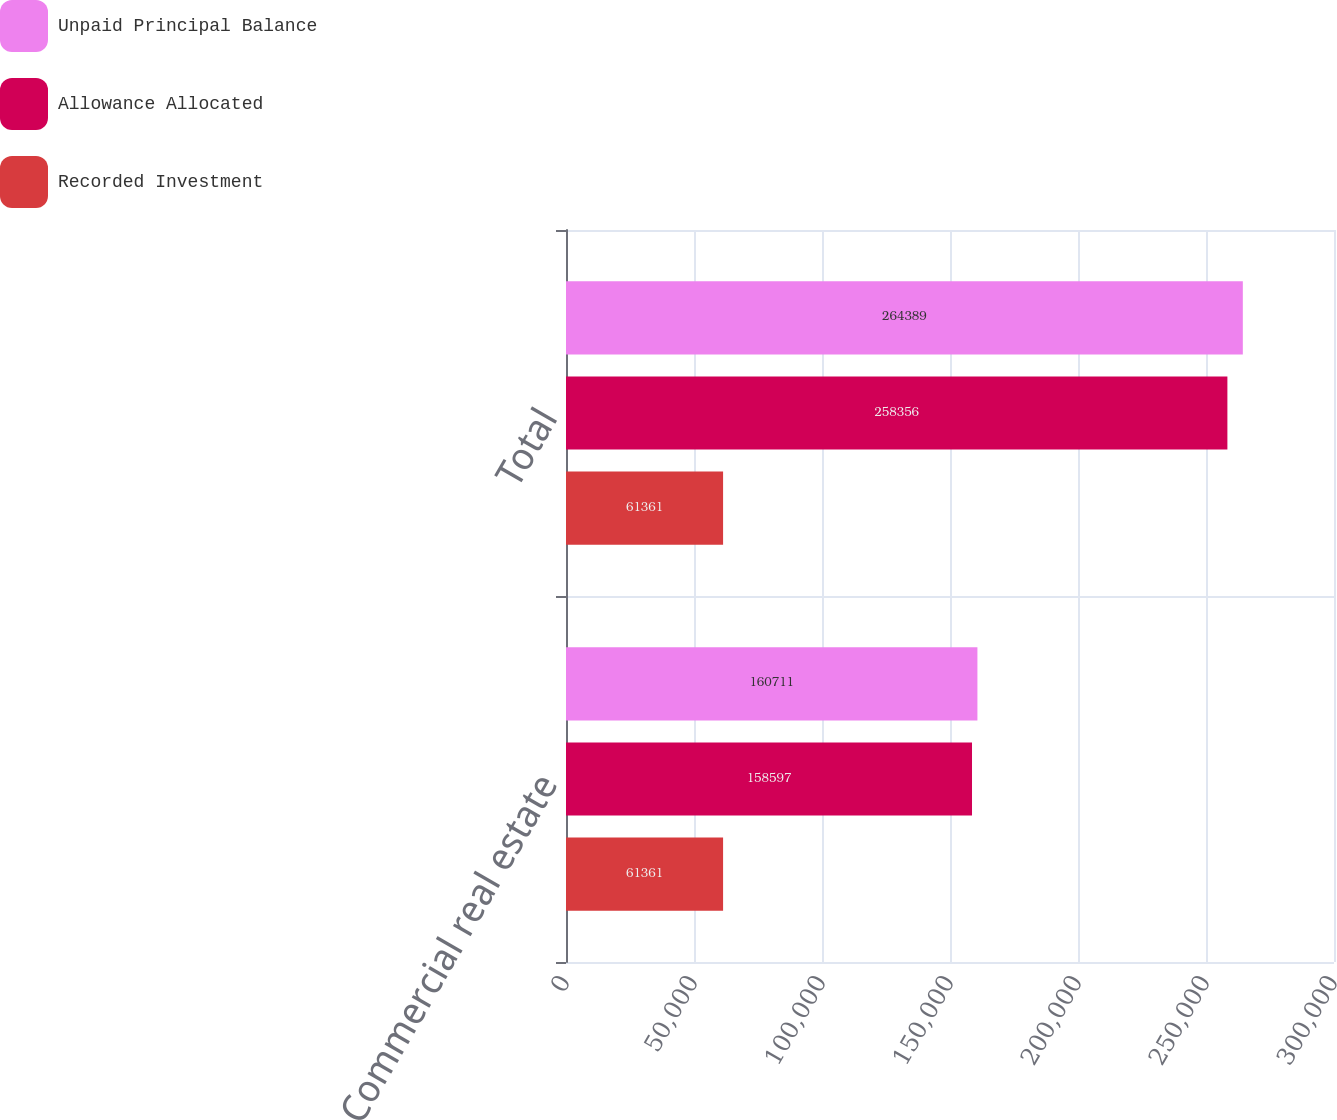Convert chart to OTSL. <chart><loc_0><loc_0><loc_500><loc_500><stacked_bar_chart><ecel><fcel>Commercial real estate<fcel>Total<nl><fcel>Unpaid Principal Balance<fcel>160711<fcel>264389<nl><fcel>Allowance Allocated<fcel>158597<fcel>258356<nl><fcel>Recorded Investment<fcel>61361<fcel>61361<nl></chart> 